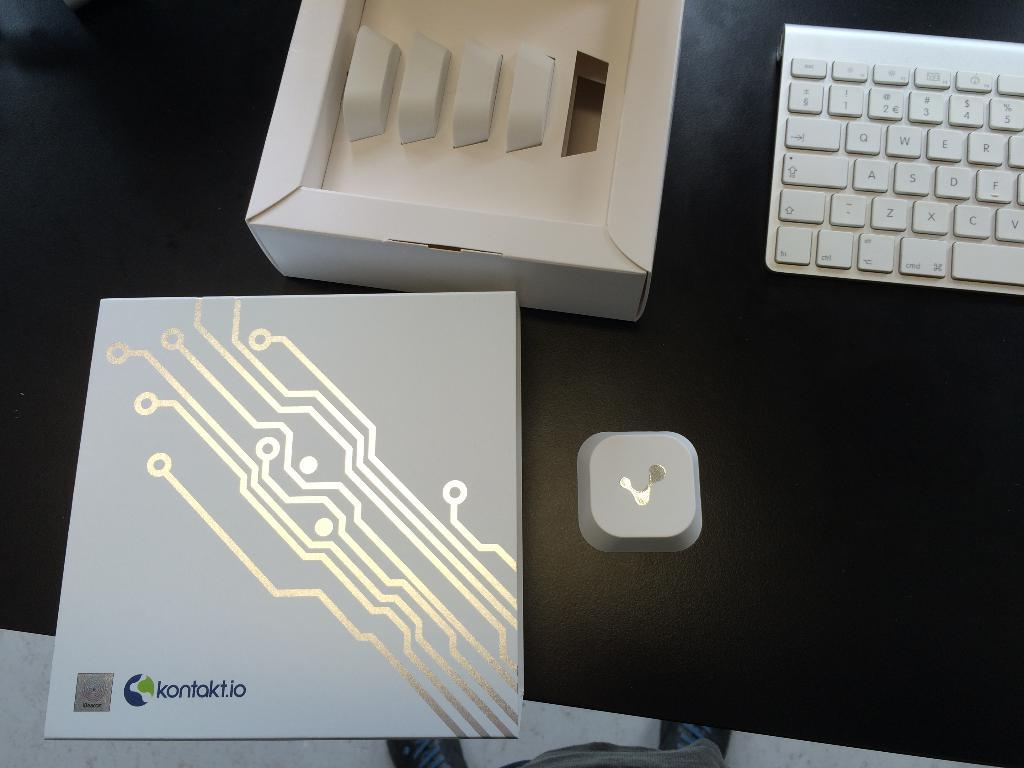<image>
Present a compact description of the photo's key features. A card with silver lines has kontakt.io at the bottom. 